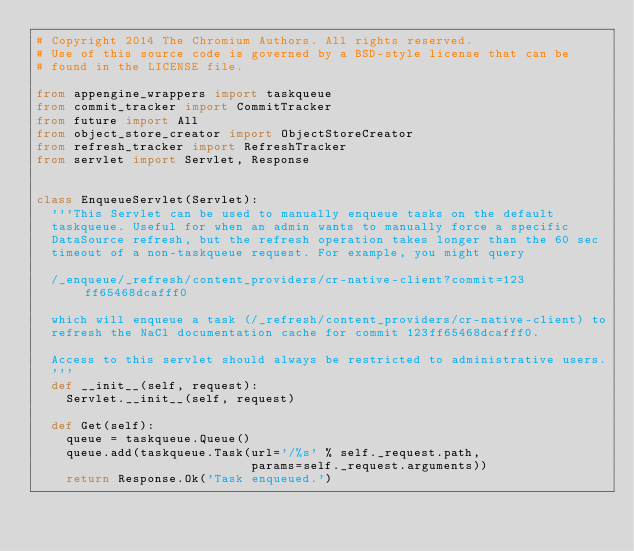Convert code to text. <code><loc_0><loc_0><loc_500><loc_500><_Python_># Copyright 2014 The Chromium Authors. All rights reserved.
# Use of this source code is governed by a BSD-style license that can be
# found in the LICENSE file.

from appengine_wrappers import taskqueue
from commit_tracker import CommitTracker
from future import All
from object_store_creator import ObjectStoreCreator
from refresh_tracker import RefreshTracker
from servlet import Servlet, Response


class EnqueueServlet(Servlet):
  '''This Servlet can be used to manually enqueue tasks on the default
  taskqueue. Useful for when an admin wants to manually force a specific
  DataSource refresh, but the refresh operation takes longer than the 60 sec
  timeout of a non-taskqueue request. For example, you might query

  /_enqueue/_refresh/content_providers/cr-native-client?commit=123ff65468dcafff0

  which will enqueue a task (/_refresh/content_providers/cr-native-client) to
  refresh the NaCl documentation cache for commit 123ff65468dcafff0.

  Access to this servlet should always be restricted to administrative users.
  '''
  def __init__(self, request):
    Servlet.__init__(self, request)

  def Get(self):
    queue = taskqueue.Queue()
    queue.add(taskqueue.Task(url='/%s' % self._request.path,
                             params=self._request.arguments))
    return Response.Ok('Task enqueued.')

</code> 